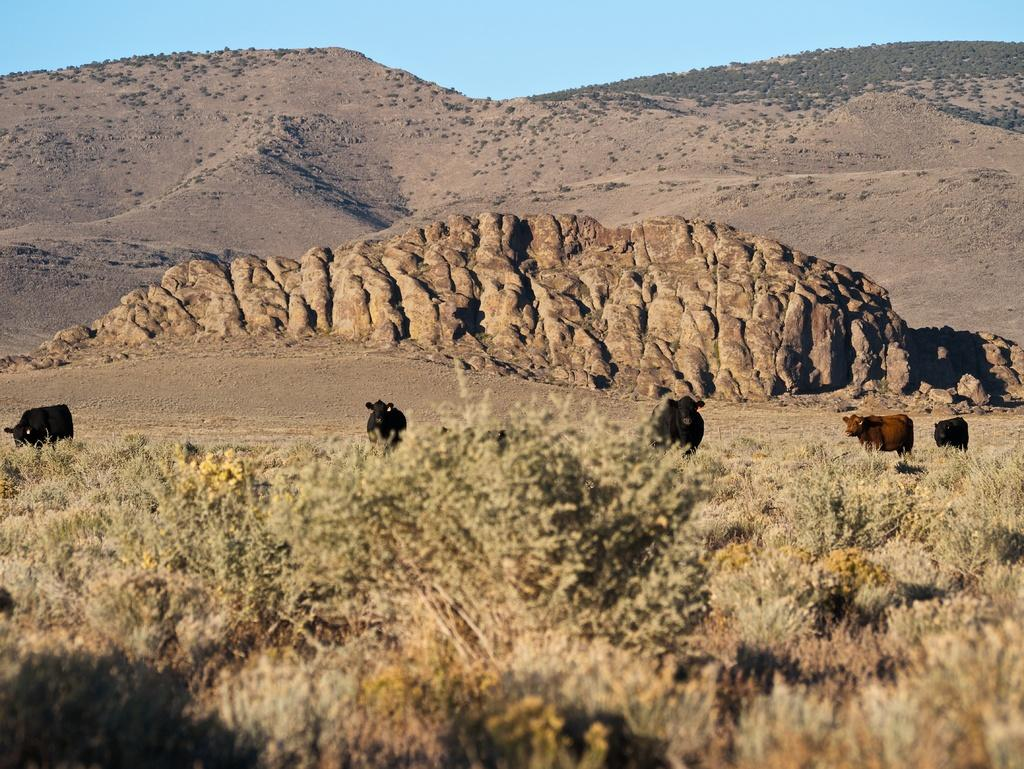What type of landscape can be seen in the image? There are hills visible in the image. How many animals are present in the image? There are five animals in the image. What type of vegetation is present in the image? There are many trees and plants in the image. What type of key is used to unlock the learning process in the image? There is no key or learning process depicted in the image; it features hills, animals, trees, and plants. What type of lipstick is being applied by the animal in the image? There are no animals applying lipstick in the image; the animals are simply present in the landscape. 